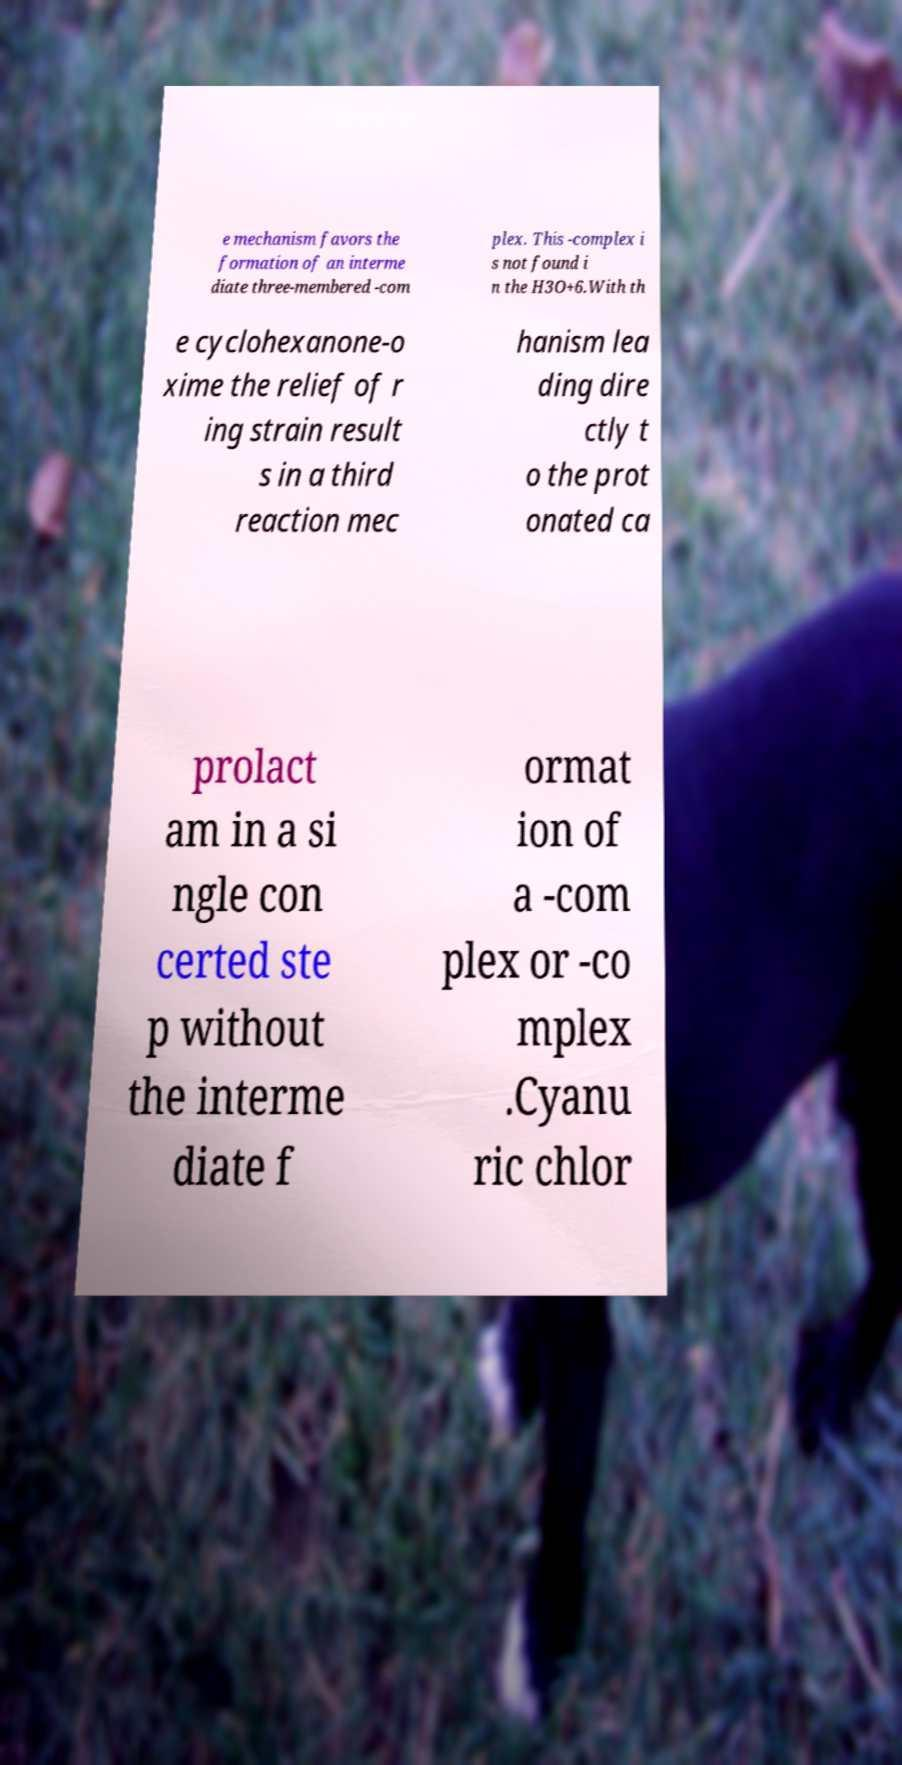Could you extract and type out the text from this image? e mechanism favors the formation of an interme diate three-membered -com plex. This -complex i s not found i n the H3O+6.With th e cyclohexanone-o xime the relief of r ing strain result s in a third reaction mec hanism lea ding dire ctly t o the prot onated ca prolact am in a si ngle con certed ste p without the interme diate f ormat ion of a -com plex or -co mplex .Cyanu ric chlor 